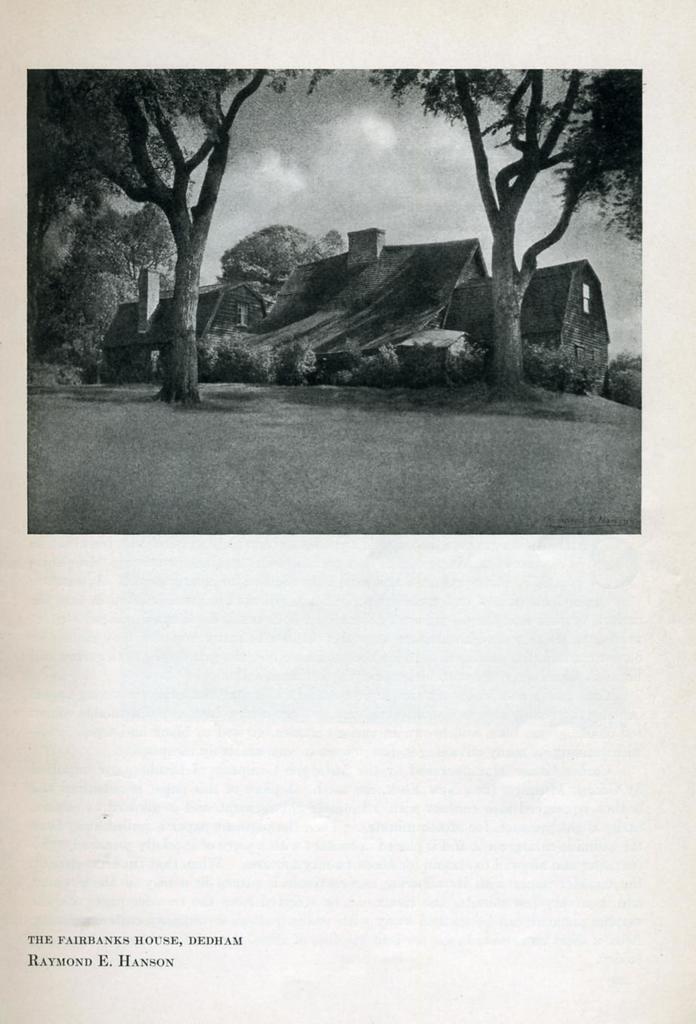Please provide a concise description of this image. In this image we can see a paper in which there is an image which has some houses, trees, bushes and top of the image there is clear sky and on bottom left of the image there are some words written on it. 